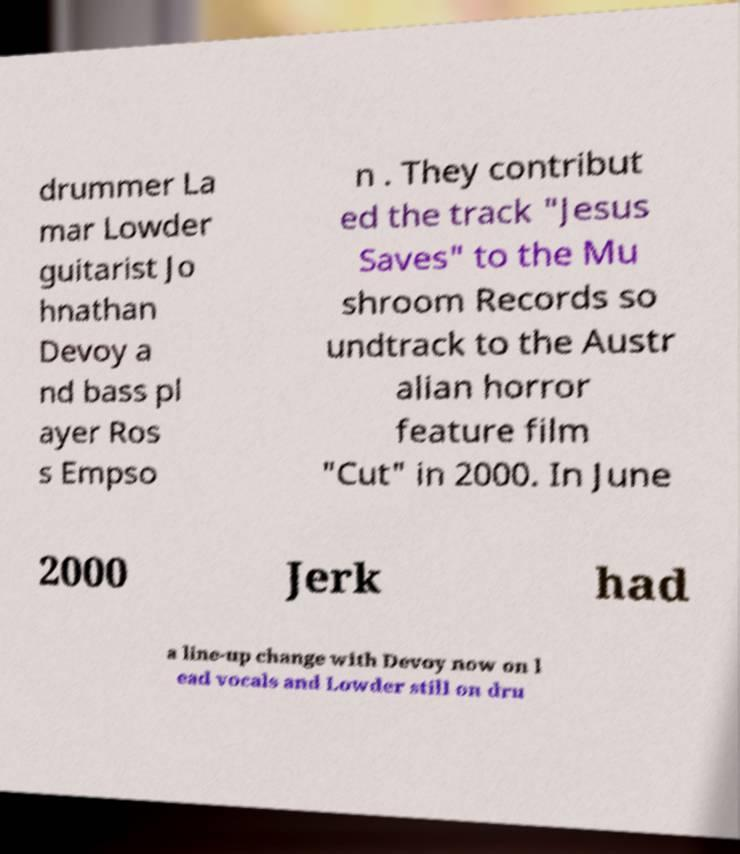Can you read and provide the text displayed in the image?This photo seems to have some interesting text. Can you extract and type it out for me? drummer La mar Lowder guitarist Jo hnathan Devoy a nd bass pl ayer Ros s Empso n . They contribut ed the track "Jesus Saves" to the Mu shroom Records so undtrack to the Austr alian horror feature film "Cut" in 2000. In June 2000 Jerk had a line-up change with Devoy now on l ead vocals and Lowder still on dru 